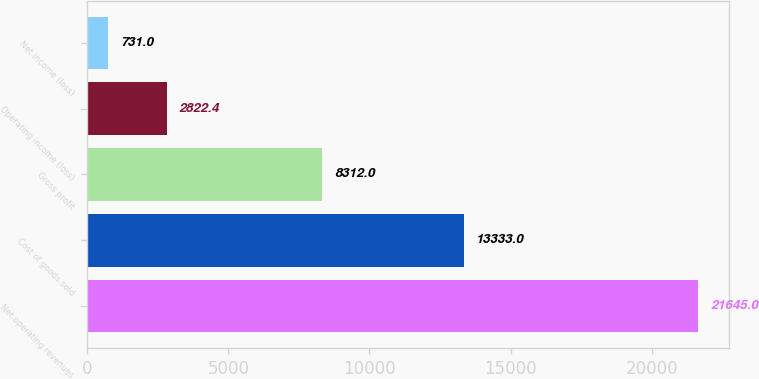<chart> <loc_0><loc_0><loc_500><loc_500><bar_chart><fcel>Net operating revenues<fcel>Cost of goods sold<fcel>Gross profit<fcel>Operating income (loss)<fcel>Net income (loss)<nl><fcel>21645<fcel>13333<fcel>8312<fcel>2822.4<fcel>731<nl></chart> 